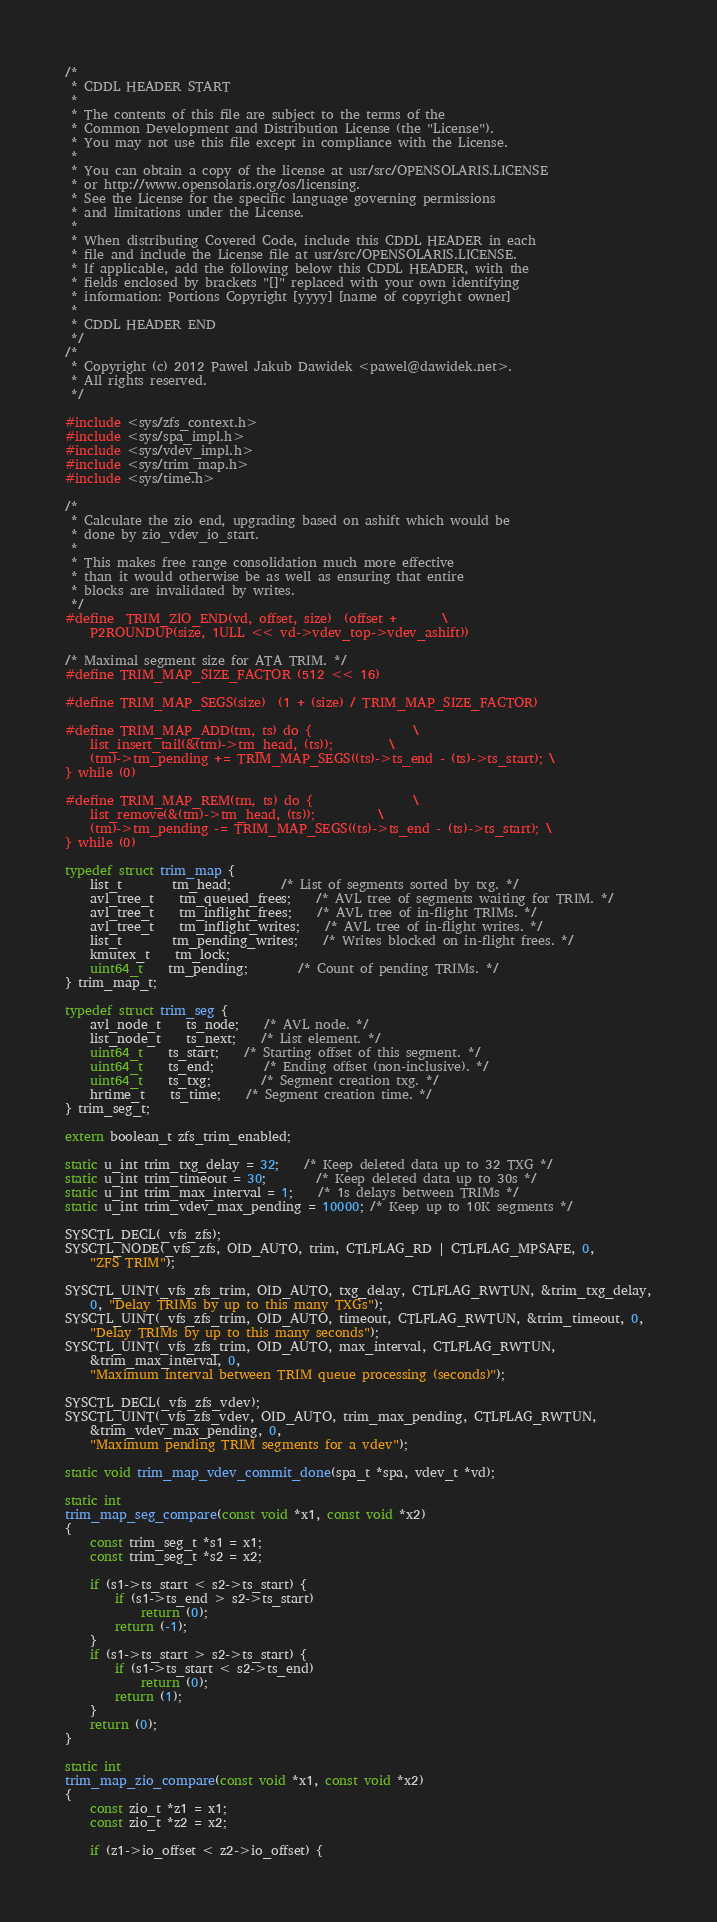Convert code to text. <code><loc_0><loc_0><loc_500><loc_500><_C_>/*
 * CDDL HEADER START
 *
 * The contents of this file are subject to the terms of the
 * Common Development and Distribution License (the "License").
 * You may not use this file except in compliance with the License.
 *
 * You can obtain a copy of the license at usr/src/OPENSOLARIS.LICENSE
 * or http://www.opensolaris.org/os/licensing.
 * See the License for the specific language governing permissions
 * and limitations under the License.
 *
 * When distributing Covered Code, include this CDDL HEADER in each
 * file and include the License file at usr/src/OPENSOLARIS.LICENSE.
 * If applicable, add the following below this CDDL HEADER, with the
 * fields enclosed by brackets "[]" replaced with your own identifying
 * information: Portions Copyright [yyyy] [name of copyright owner]
 *
 * CDDL HEADER END
 */
/*
 * Copyright (c) 2012 Pawel Jakub Dawidek <pawel@dawidek.net>.
 * All rights reserved.
 */

#include <sys/zfs_context.h>
#include <sys/spa_impl.h>
#include <sys/vdev_impl.h>
#include <sys/trim_map.h>
#include <sys/time.h>

/*
 * Calculate the zio end, upgrading based on ashift which would be
 * done by zio_vdev_io_start.
 *
 * This makes free range consolidation much more effective
 * than it would otherwise be as well as ensuring that entire
 * blocks are invalidated by writes.
 */
#define	TRIM_ZIO_END(vd, offset, size)	(offset +		\
 	P2ROUNDUP(size, 1ULL << vd->vdev_top->vdev_ashift))

/* Maximal segment size for ATA TRIM. */
#define TRIM_MAP_SIZE_FACTOR	(512 << 16)

#define TRIM_MAP_SEGS(size)	(1 + (size) / TRIM_MAP_SIZE_FACTOR)

#define TRIM_MAP_ADD(tm, ts)	do {				\
	list_insert_tail(&(tm)->tm_head, (ts));			\
	(tm)->tm_pending += TRIM_MAP_SEGS((ts)->ts_end - (ts)->ts_start); \
} while (0)

#define TRIM_MAP_REM(tm, ts)	do {				\
	list_remove(&(tm)->tm_head, (ts));			\
	(tm)->tm_pending -= TRIM_MAP_SEGS((ts)->ts_end - (ts)->ts_start); \
} while (0)

typedef struct trim_map {
	list_t		tm_head;		/* List of segments sorted by txg. */
	avl_tree_t	tm_queued_frees;	/* AVL tree of segments waiting for TRIM. */
	avl_tree_t	tm_inflight_frees;	/* AVL tree of in-flight TRIMs. */
	avl_tree_t	tm_inflight_writes;	/* AVL tree of in-flight writes. */
	list_t		tm_pending_writes;	/* Writes blocked on in-flight frees. */
	kmutex_t	tm_lock;
	uint64_t	tm_pending;		/* Count of pending TRIMs. */
} trim_map_t;

typedef struct trim_seg {
	avl_node_t	ts_node;	/* AVL node. */
	list_node_t	ts_next;	/* List element. */
	uint64_t	ts_start;	/* Starting offset of this segment. */
	uint64_t	ts_end;		/* Ending offset (non-inclusive). */
	uint64_t	ts_txg;		/* Segment creation txg. */
	hrtime_t	ts_time;	/* Segment creation time. */
} trim_seg_t;

extern boolean_t zfs_trim_enabled;

static u_int trim_txg_delay = 32;	/* Keep deleted data up to 32 TXG */
static u_int trim_timeout = 30;		/* Keep deleted data up to 30s */
static u_int trim_max_interval = 1;	/* 1s delays between TRIMs */
static u_int trim_vdev_max_pending = 10000; /* Keep up to 10K segments */

SYSCTL_DECL(_vfs_zfs);
SYSCTL_NODE(_vfs_zfs, OID_AUTO, trim, CTLFLAG_RD | CTLFLAG_MPSAFE, 0,
    "ZFS TRIM");

SYSCTL_UINT(_vfs_zfs_trim, OID_AUTO, txg_delay, CTLFLAG_RWTUN, &trim_txg_delay,
    0, "Delay TRIMs by up to this many TXGs");
SYSCTL_UINT(_vfs_zfs_trim, OID_AUTO, timeout, CTLFLAG_RWTUN, &trim_timeout, 0,
    "Delay TRIMs by up to this many seconds");
SYSCTL_UINT(_vfs_zfs_trim, OID_AUTO, max_interval, CTLFLAG_RWTUN,
    &trim_max_interval, 0,
    "Maximum interval between TRIM queue processing (seconds)");

SYSCTL_DECL(_vfs_zfs_vdev);
SYSCTL_UINT(_vfs_zfs_vdev, OID_AUTO, trim_max_pending, CTLFLAG_RWTUN,
    &trim_vdev_max_pending, 0,
    "Maximum pending TRIM segments for a vdev");

static void trim_map_vdev_commit_done(spa_t *spa, vdev_t *vd);

static int
trim_map_seg_compare(const void *x1, const void *x2)
{
	const trim_seg_t *s1 = x1;
	const trim_seg_t *s2 = x2;

	if (s1->ts_start < s2->ts_start) {
		if (s1->ts_end > s2->ts_start)
			return (0);
		return (-1);
	}
	if (s1->ts_start > s2->ts_start) {
		if (s1->ts_start < s2->ts_end)
			return (0);
		return (1);
	}
	return (0);
}

static int
trim_map_zio_compare(const void *x1, const void *x2)
{
	const zio_t *z1 = x1;
	const zio_t *z2 = x2;

	if (z1->io_offset < z2->io_offset) {</code> 